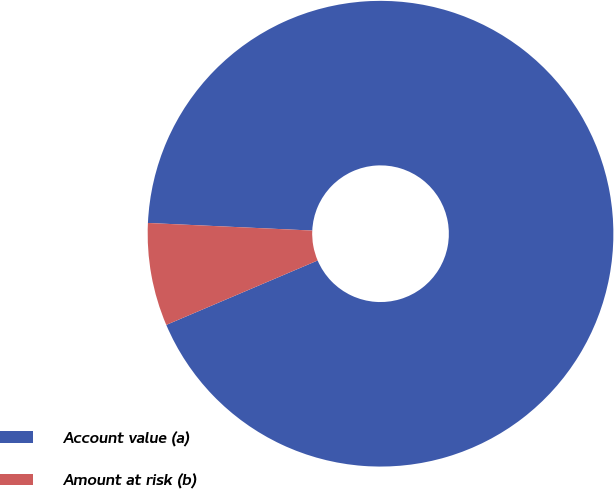<chart> <loc_0><loc_0><loc_500><loc_500><pie_chart><fcel>Account value (a)<fcel>Amount at risk (b)<nl><fcel>92.86%<fcel>7.14%<nl></chart> 